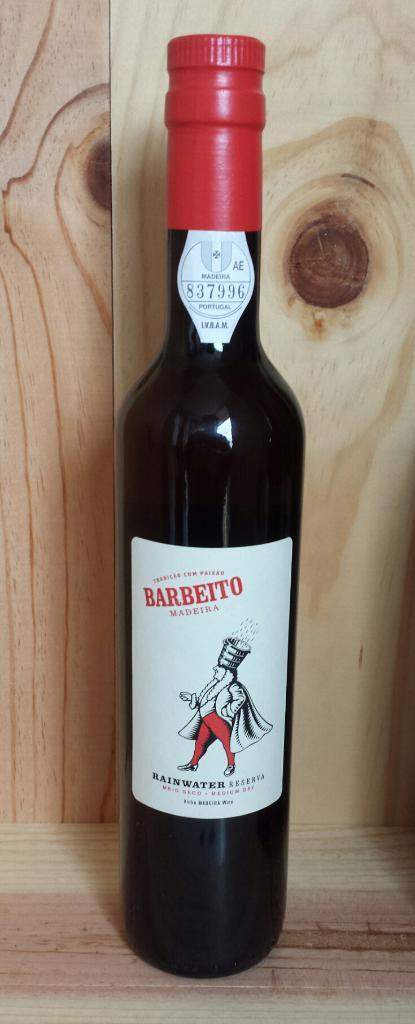Provide a one-sentence caption for the provided image. An unopened bottle of medium dry wine sits on a wood surface. 